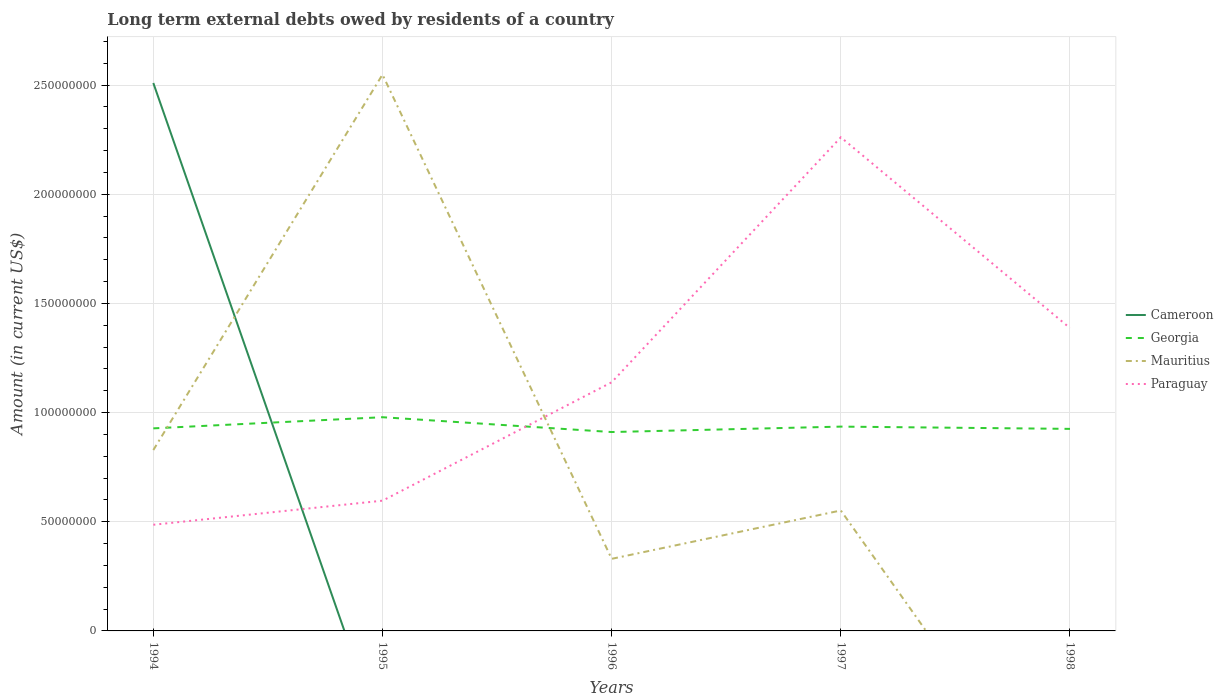How many different coloured lines are there?
Offer a very short reply. 4. Is the number of lines equal to the number of legend labels?
Offer a terse response. No. Across all years, what is the maximum amount of long-term external debts owed by residents in Georgia?
Keep it short and to the point. 9.11e+07. What is the total amount of long-term external debts owed by residents in Paraguay in the graph?
Your answer should be compact. -1.77e+08. What is the difference between the highest and the second highest amount of long-term external debts owed by residents in Mauritius?
Keep it short and to the point. 2.55e+08. What is the difference between the highest and the lowest amount of long-term external debts owed by residents in Cameroon?
Offer a very short reply. 1. Is the amount of long-term external debts owed by residents in Mauritius strictly greater than the amount of long-term external debts owed by residents in Cameroon over the years?
Your response must be concise. No. How many lines are there?
Provide a succinct answer. 4. What is the difference between two consecutive major ticks on the Y-axis?
Offer a terse response. 5.00e+07. Does the graph contain any zero values?
Provide a succinct answer. Yes. Does the graph contain grids?
Give a very brief answer. Yes. How many legend labels are there?
Offer a very short reply. 4. How are the legend labels stacked?
Provide a short and direct response. Vertical. What is the title of the graph?
Your answer should be very brief. Long term external debts owed by residents of a country. What is the Amount (in current US$) in Cameroon in 1994?
Give a very brief answer. 2.51e+08. What is the Amount (in current US$) of Georgia in 1994?
Give a very brief answer. 9.28e+07. What is the Amount (in current US$) in Mauritius in 1994?
Provide a succinct answer. 8.28e+07. What is the Amount (in current US$) in Paraguay in 1994?
Your answer should be very brief. 4.86e+07. What is the Amount (in current US$) of Cameroon in 1995?
Your response must be concise. 0. What is the Amount (in current US$) in Georgia in 1995?
Your answer should be compact. 9.79e+07. What is the Amount (in current US$) of Mauritius in 1995?
Your answer should be compact. 2.55e+08. What is the Amount (in current US$) of Paraguay in 1995?
Provide a succinct answer. 5.97e+07. What is the Amount (in current US$) in Georgia in 1996?
Provide a short and direct response. 9.11e+07. What is the Amount (in current US$) in Mauritius in 1996?
Your response must be concise. 3.30e+07. What is the Amount (in current US$) in Paraguay in 1996?
Give a very brief answer. 1.14e+08. What is the Amount (in current US$) in Georgia in 1997?
Ensure brevity in your answer.  9.36e+07. What is the Amount (in current US$) of Mauritius in 1997?
Your answer should be very brief. 5.52e+07. What is the Amount (in current US$) of Paraguay in 1997?
Make the answer very short. 2.26e+08. What is the Amount (in current US$) in Georgia in 1998?
Ensure brevity in your answer.  9.25e+07. What is the Amount (in current US$) in Mauritius in 1998?
Give a very brief answer. 0. What is the Amount (in current US$) of Paraguay in 1998?
Provide a succinct answer. 1.39e+08. Across all years, what is the maximum Amount (in current US$) in Cameroon?
Your response must be concise. 2.51e+08. Across all years, what is the maximum Amount (in current US$) in Georgia?
Ensure brevity in your answer.  9.79e+07. Across all years, what is the maximum Amount (in current US$) of Mauritius?
Offer a terse response. 2.55e+08. Across all years, what is the maximum Amount (in current US$) in Paraguay?
Offer a very short reply. 2.26e+08. Across all years, what is the minimum Amount (in current US$) in Cameroon?
Keep it short and to the point. 0. Across all years, what is the minimum Amount (in current US$) of Georgia?
Your answer should be very brief. 9.11e+07. Across all years, what is the minimum Amount (in current US$) of Paraguay?
Keep it short and to the point. 4.86e+07. What is the total Amount (in current US$) in Cameroon in the graph?
Keep it short and to the point. 2.51e+08. What is the total Amount (in current US$) in Georgia in the graph?
Provide a short and direct response. 4.68e+08. What is the total Amount (in current US$) of Mauritius in the graph?
Ensure brevity in your answer.  4.26e+08. What is the total Amount (in current US$) of Paraguay in the graph?
Ensure brevity in your answer.  5.87e+08. What is the difference between the Amount (in current US$) of Georgia in 1994 and that in 1995?
Keep it short and to the point. -5.10e+06. What is the difference between the Amount (in current US$) of Mauritius in 1994 and that in 1995?
Provide a short and direct response. -1.72e+08. What is the difference between the Amount (in current US$) of Paraguay in 1994 and that in 1995?
Your response must be concise. -1.10e+07. What is the difference between the Amount (in current US$) of Georgia in 1994 and that in 1996?
Your answer should be compact. 1.69e+06. What is the difference between the Amount (in current US$) in Mauritius in 1994 and that in 1996?
Keep it short and to the point. 4.98e+07. What is the difference between the Amount (in current US$) of Paraguay in 1994 and that in 1996?
Your response must be concise. -6.53e+07. What is the difference between the Amount (in current US$) in Georgia in 1994 and that in 1997?
Provide a succinct answer. -7.97e+05. What is the difference between the Amount (in current US$) of Mauritius in 1994 and that in 1997?
Ensure brevity in your answer.  2.77e+07. What is the difference between the Amount (in current US$) in Paraguay in 1994 and that in 1997?
Your response must be concise. -1.77e+08. What is the difference between the Amount (in current US$) of Georgia in 1994 and that in 1998?
Your answer should be compact. 2.41e+05. What is the difference between the Amount (in current US$) of Paraguay in 1994 and that in 1998?
Keep it short and to the point. -9.01e+07. What is the difference between the Amount (in current US$) of Georgia in 1995 and that in 1996?
Give a very brief answer. 6.79e+06. What is the difference between the Amount (in current US$) of Mauritius in 1995 and that in 1996?
Offer a terse response. 2.22e+08. What is the difference between the Amount (in current US$) of Paraguay in 1995 and that in 1996?
Make the answer very short. -5.42e+07. What is the difference between the Amount (in current US$) in Georgia in 1995 and that in 1997?
Your answer should be compact. 4.30e+06. What is the difference between the Amount (in current US$) in Mauritius in 1995 and that in 1997?
Offer a terse response. 2.00e+08. What is the difference between the Amount (in current US$) of Paraguay in 1995 and that in 1997?
Offer a very short reply. -1.66e+08. What is the difference between the Amount (in current US$) in Georgia in 1995 and that in 1998?
Provide a short and direct response. 5.34e+06. What is the difference between the Amount (in current US$) in Paraguay in 1995 and that in 1998?
Your answer should be very brief. -7.90e+07. What is the difference between the Amount (in current US$) in Georgia in 1996 and that in 1997?
Ensure brevity in your answer.  -2.48e+06. What is the difference between the Amount (in current US$) of Mauritius in 1996 and that in 1997?
Give a very brief answer. -2.21e+07. What is the difference between the Amount (in current US$) of Paraguay in 1996 and that in 1997?
Provide a short and direct response. -1.12e+08. What is the difference between the Amount (in current US$) in Georgia in 1996 and that in 1998?
Provide a succinct answer. -1.45e+06. What is the difference between the Amount (in current US$) of Paraguay in 1996 and that in 1998?
Keep it short and to the point. -2.48e+07. What is the difference between the Amount (in current US$) of Georgia in 1997 and that in 1998?
Keep it short and to the point. 1.04e+06. What is the difference between the Amount (in current US$) in Paraguay in 1997 and that in 1998?
Your answer should be compact. 8.74e+07. What is the difference between the Amount (in current US$) in Cameroon in 1994 and the Amount (in current US$) in Georgia in 1995?
Keep it short and to the point. 1.53e+08. What is the difference between the Amount (in current US$) of Cameroon in 1994 and the Amount (in current US$) of Mauritius in 1995?
Keep it short and to the point. -3.86e+06. What is the difference between the Amount (in current US$) of Cameroon in 1994 and the Amount (in current US$) of Paraguay in 1995?
Your response must be concise. 1.91e+08. What is the difference between the Amount (in current US$) in Georgia in 1994 and the Amount (in current US$) in Mauritius in 1995?
Offer a very short reply. -1.62e+08. What is the difference between the Amount (in current US$) of Georgia in 1994 and the Amount (in current US$) of Paraguay in 1995?
Keep it short and to the point. 3.31e+07. What is the difference between the Amount (in current US$) in Mauritius in 1994 and the Amount (in current US$) in Paraguay in 1995?
Keep it short and to the point. 2.32e+07. What is the difference between the Amount (in current US$) in Cameroon in 1994 and the Amount (in current US$) in Georgia in 1996?
Give a very brief answer. 1.60e+08. What is the difference between the Amount (in current US$) in Cameroon in 1994 and the Amount (in current US$) in Mauritius in 1996?
Make the answer very short. 2.18e+08. What is the difference between the Amount (in current US$) in Cameroon in 1994 and the Amount (in current US$) in Paraguay in 1996?
Keep it short and to the point. 1.37e+08. What is the difference between the Amount (in current US$) in Georgia in 1994 and the Amount (in current US$) in Mauritius in 1996?
Provide a short and direct response. 5.98e+07. What is the difference between the Amount (in current US$) of Georgia in 1994 and the Amount (in current US$) of Paraguay in 1996?
Your response must be concise. -2.11e+07. What is the difference between the Amount (in current US$) in Mauritius in 1994 and the Amount (in current US$) in Paraguay in 1996?
Keep it short and to the point. -3.10e+07. What is the difference between the Amount (in current US$) of Cameroon in 1994 and the Amount (in current US$) of Georgia in 1997?
Give a very brief answer. 1.57e+08. What is the difference between the Amount (in current US$) of Cameroon in 1994 and the Amount (in current US$) of Mauritius in 1997?
Give a very brief answer. 1.96e+08. What is the difference between the Amount (in current US$) in Cameroon in 1994 and the Amount (in current US$) in Paraguay in 1997?
Offer a very short reply. 2.49e+07. What is the difference between the Amount (in current US$) of Georgia in 1994 and the Amount (in current US$) of Mauritius in 1997?
Provide a succinct answer. 3.76e+07. What is the difference between the Amount (in current US$) in Georgia in 1994 and the Amount (in current US$) in Paraguay in 1997?
Your answer should be very brief. -1.33e+08. What is the difference between the Amount (in current US$) of Mauritius in 1994 and the Amount (in current US$) of Paraguay in 1997?
Offer a very short reply. -1.43e+08. What is the difference between the Amount (in current US$) of Cameroon in 1994 and the Amount (in current US$) of Georgia in 1998?
Give a very brief answer. 1.58e+08. What is the difference between the Amount (in current US$) of Cameroon in 1994 and the Amount (in current US$) of Paraguay in 1998?
Your answer should be very brief. 1.12e+08. What is the difference between the Amount (in current US$) in Georgia in 1994 and the Amount (in current US$) in Paraguay in 1998?
Your answer should be very brief. -4.59e+07. What is the difference between the Amount (in current US$) in Mauritius in 1994 and the Amount (in current US$) in Paraguay in 1998?
Make the answer very short. -5.58e+07. What is the difference between the Amount (in current US$) of Georgia in 1995 and the Amount (in current US$) of Mauritius in 1996?
Your answer should be compact. 6.49e+07. What is the difference between the Amount (in current US$) of Georgia in 1995 and the Amount (in current US$) of Paraguay in 1996?
Provide a succinct answer. -1.60e+07. What is the difference between the Amount (in current US$) of Mauritius in 1995 and the Amount (in current US$) of Paraguay in 1996?
Your response must be concise. 1.41e+08. What is the difference between the Amount (in current US$) in Georgia in 1995 and the Amount (in current US$) in Mauritius in 1997?
Your answer should be compact. 4.27e+07. What is the difference between the Amount (in current US$) in Georgia in 1995 and the Amount (in current US$) in Paraguay in 1997?
Your response must be concise. -1.28e+08. What is the difference between the Amount (in current US$) in Mauritius in 1995 and the Amount (in current US$) in Paraguay in 1997?
Your answer should be compact. 2.87e+07. What is the difference between the Amount (in current US$) of Georgia in 1995 and the Amount (in current US$) of Paraguay in 1998?
Keep it short and to the point. -4.08e+07. What is the difference between the Amount (in current US$) of Mauritius in 1995 and the Amount (in current US$) of Paraguay in 1998?
Keep it short and to the point. 1.16e+08. What is the difference between the Amount (in current US$) of Georgia in 1996 and the Amount (in current US$) of Mauritius in 1997?
Offer a very short reply. 3.59e+07. What is the difference between the Amount (in current US$) in Georgia in 1996 and the Amount (in current US$) in Paraguay in 1997?
Ensure brevity in your answer.  -1.35e+08. What is the difference between the Amount (in current US$) of Mauritius in 1996 and the Amount (in current US$) of Paraguay in 1997?
Provide a short and direct response. -1.93e+08. What is the difference between the Amount (in current US$) in Georgia in 1996 and the Amount (in current US$) in Paraguay in 1998?
Keep it short and to the point. -4.76e+07. What is the difference between the Amount (in current US$) of Mauritius in 1996 and the Amount (in current US$) of Paraguay in 1998?
Your answer should be very brief. -1.06e+08. What is the difference between the Amount (in current US$) of Georgia in 1997 and the Amount (in current US$) of Paraguay in 1998?
Provide a succinct answer. -4.51e+07. What is the difference between the Amount (in current US$) of Mauritius in 1997 and the Amount (in current US$) of Paraguay in 1998?
Ensure brevity in your answer.  -8.35e+07. What is the average Amount (in current US$) in Cameroon per year?
Give a very brief answer. 5.02e+07. What is the average Amount (in current US$) of Georgia per year?
Your answer should be very brief. 9.36e+07. What is the average Amount (in current US$) in Mauritius per year?
Ensure brevity in your answer.  8.52e+07. What is the average Amount (in current US$) of Paraguay per year?
Your answer should be compact. 1.17e+08. In the year 1994, what is the difference between the Amount (in current US$) of Cameroon and Amount (in current US$) of Georgia?
Offer a terse response. 1.58e+08. In the year 1994, what is the difference between the Amount (in current US$) of Cameroon and Amount (in current US$) of Mauritius?
Your response must be concise. 1.68e+08. In the year 1994, what is the difference between the Amount (in current US$) of Cameroon and Amount (in current US$) of Paraguay?
Offer a terse response. 2.02e+08. In the year 1994, what is the difference between the Amount (in current US$) in Georgia and Amount (in current US$) in Mauritius?
Your response must be concise. 9.93e+06. In the year 1994, what is the difference between the Amount (in current US$) of Georgia and Amount (in current US$) of Paraguay?
Your answer should be very brief. 4.42e+07. In the year 1994, what is the difference between the Amount (in current US$) in Mauritius and Amount (in current US$) in Paraguay?
Offer a terse response. 3.42e+07. In the year 1995, what is the difference between the Amount (in current US$) in Georgia and Amount (in current US$) in Mauritius?
Provide a short and direct response. -1.57e+08. In the year 1995, what is the difference between the Amount (in current US$) of Georgia and Amount (in current US$) of Paraguay?
Provide a short and direct response. 3.82e+07. In the year 1995, what is the difference between the Amount (in current US$) in Mauritius and Amount (in current US$) in Paraguay?
Provide a short and direct response. 1.95e+08. In the year 1996, what is the difference between the Amount (in current US$) in Georgia and Amount (in current US$) in Mauritius?
Offer a terse response. 5.81e+07. In the year 1996, what is the difference between the Amount (in current US$) of Georgia and Amount (in current US$) of Paraguay?
Ensure brevity in your answer.  -2.28e+07. In the year 1996, what is the difference between the Amount (in current US$) in Mauritius and Amount (in current US$) in Paraguay?
Your answer should be compact. -8.09e+07. In the year 1997, what is the difference between the Amount (in current US$) in Georgia and Amount (in current US$) in Mauritius?
Make the answer very short. 3.84e+07. In the year 1997, what is the difference between the Amount (in current US$) in Georgia and Amount (in current US$) in Paraguay?
Your answer should be compact. -1.33e+08. In the year 1997, what is the difference between the Amount (in current US$) of Mauritius and Amount (in current US$) of Paraguay?
Provide a short and direct response. -1.71e+08. In the year 1998, what is the difference between the Amount (in current US$) in Georgia and Amount (in current US$) in Paraguay?
Provide a succinct answer. -4.62e+07. What is the ratio of the Amount (in current US$) in Georgia in 1994 to that in 1995?
Give a very brief answer. 0.95. What is the ratio of the Amount (in current US$) in Mauritius in 1994 to that in 1995?
Your answer should be very brief. 0.33. What is the ratio of the Amount (in current US$) in Paraguay in 1994 to that in 1995?
Keep it short and to the point. 0.82. What is the ratio of the Amount (in current US$) in Georgia in 1994 to that in 1996?
Your answer should be compact. 1.02. What is the ratio of the Amount (in current US$) of Mauritius in 1994 to that in 1996?
Make the answer very short. 2.51. What is the ratio of the Amount (in current US$) in Paraguay in 1994 to that in 1996?
Provide a succinct answer. 0.43. What is the ratio of the Amount (in current US$) in Mauritius in 1994 to that in 1997?
Give a very brief answer. 1.5. What is the ratio of the Amount (in current US$) of Paraguay in 1994 to that in 1997?
Your response must be concise. 0.22. What is the ratio of the Amount (in current US$) in Georgia in 1994 to that in 1998?
Your answer should be compact. 1. What is the ratio of the Amount (in current US$) of Paraguay in 1994 to that in 1998?
Offer a terse response. 0.35. What is the ratio of the Amount (in current US$) of Georgia in 1995 to that in 1996?
Your answer should be compact. 1.07. What is the ratio of the Amount (in current US$) in Mauritius in 1995 to that in 1996?
Your answer should be very brief. 7.72. What is the ratio of the Amount (in current US$) in Paraguay in 1995 to that in 1996?
Give a very brief answer. 0.52. What is the ratio of the Amount (in current US$) of Georgia in 1995 to that in 1997?
Your response must be concise. 1.05. What is the ratio of the Amount (in current US$) in Mauritius in 1995 to that in 1997?
Give a very brief answer. 4.62. What is the ratio of the Amount (in current US$) in Paraguay in 1995 to that in 1997?
Offer a terse response. 0.26. What is the ratio of the Amount (in current US$) in Georgia in 1995 to that in 1998?
Your answer should be very brief. 1.06. What is the ratio of the Amount (in current US$) of Paraguay in 1995 to that in 1998?
Your answer should be compact. 0.43. What is the ratio of the Amount (in current US$) in Georgia in 1996 to that in 1997?
Give a very brief answer. 0.97. What is the ratio of the Amount (in current US$) in Mauritius in 1996 to that in 1997?
Provide a succinct answer. 0.6. What is the ratio of the Amount (in current US$) of Paraguay in 1996 to that in 1997?
Ensure brevity in your answer.  0.5. What is the ratio of the Amount (in current US$) of Georgia in 1996 to that in 1998?
Offer a very short reply. 0.98. What is the ratio of the Amount (in current US$) of Paraguay in 1996 to that in 1998?
Provide a short and direct response. 0.82. What is the ratio of the Amount (in current US$) of Georgia in 1997 to that in 1998?
Offer a very short reply. 1.01. What is the ratio of the Amount (in current US$) in Paraguay in 1997 to that in 1998?
Offer a terse response. 1.63. What is the difference between the highest and the second highest Amount (in current US$) in Georgia?
Offer a very short reply. 4.30e+06. What is the difference between the highest and the second highest Amount (in current US$) of Mauritius?
Your response must be concise. 1.72e+08. What is the difference between the highest and the second highest Amount (in current US$) of Paraguay?
Provide a succinct answer. 8.74e+07. What is the difference between the highest and the lowest Amount (in current US$) of Cameroon?
Your answer should be very brief. 2.51e+08. What is the difference between the highest and the lowest Amount (in current US$) in Georgia?
Keep it short and to the point. 6.79e+06. What is the difference between the highest and the lowest Amount (in current US$) in Mauritius?
Keep it short and to the point. 2.55e+08. What is the difference between the highest and the lowest Amount (in current US$) of Paraguay?
Offer a very short reply. 1.77e+08. 